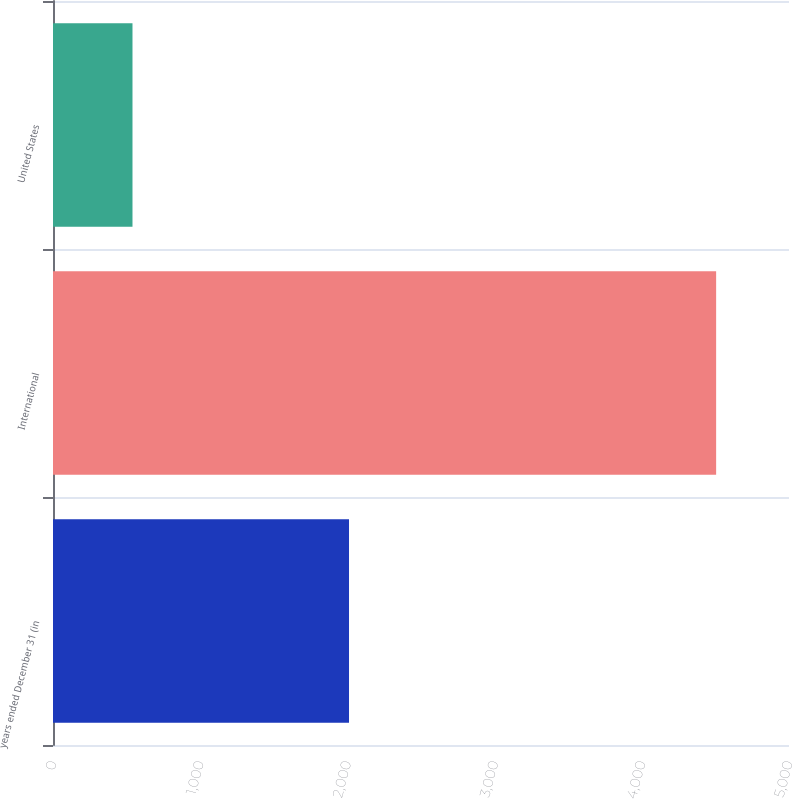Convert chart to OTSL. <chart><loc_0><loc_0><loc_500><loc_500><bar_chart><fcel>years ended December 31 (in<fcel>International<fcel>United States<nl><fcel>2011<fcel>4505<fcel>540<nl></chart> 